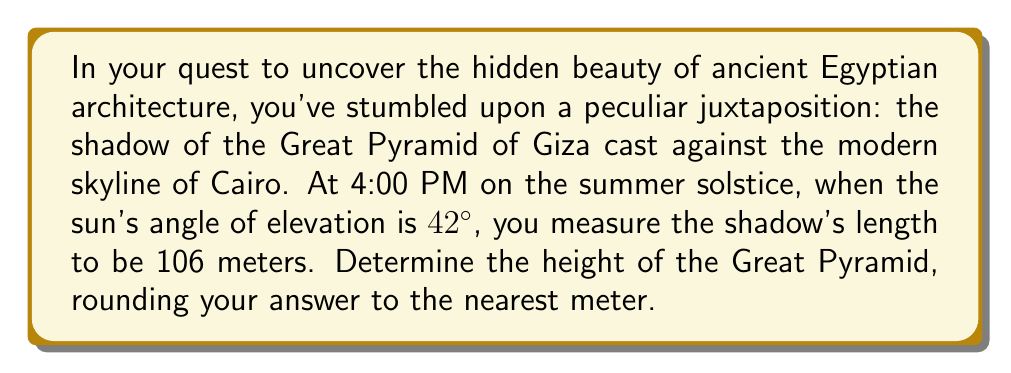Help me with this question. Let's approach this problem step-by-step, using trigonometry:

1) First, let's visualize the scenario:

[asy]
import geometry;

size(200);
pair A = (0,0), B = (106,0), C = (0,88);
draw(A--B--C--A);
draw(rightanglemark(A,B,C,8));

label("Ground", (53,-5), S);
label("Shadow", (53,0), N);
label("Pyramid", (0,44), W);
label("106 m", (53,-2), S);
label("h", (-2,44), W);
label("42°", (5,5), NE);

draw(arc(A,10,0,42),Arrow);
[/asy]

2) In this right-angled triangle, we know:
   - The adjacent side (shadow length) = 106 meters
   - The angle of elevation = 42°
   - We need to find the opposite side (height of the pyramid)

3) The trigonometric ratio that relates the opposite side to the adjacent side is the tangent:

   $$ \tan \theta = \frac{\text{opposite}}{\text{adjacent}} $$

4) Substituting our known values:

   $$ \tan 42° = \frac{h}{106} $$

5) Solving for $h$:

   $$ h = 106 \times \tan 42° $$

6) Using a calculator (or trigonometric tables):

   $$ h = 106 \times 0.90040 = 95.4424 \text{ meters} $$

7) Rounding to the nearest meter:

   $$ h \approx 95 \text{ meters} $$
Answer: 95 meters 